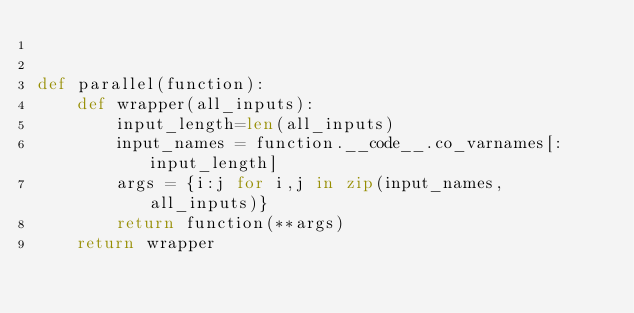<code> <loc_0><loc_0><loc_500><loc_500><_Python_>

def parallel(function):
    def wrapper(all_inputs):
        input_length=len(all_inputs)
        input_names = function.__code__.co_varnames[:input_length]
        args = {i:j for i,j in zip(input_names, all_inputs)}
        return function(**args)
    return wrapper
</code> 